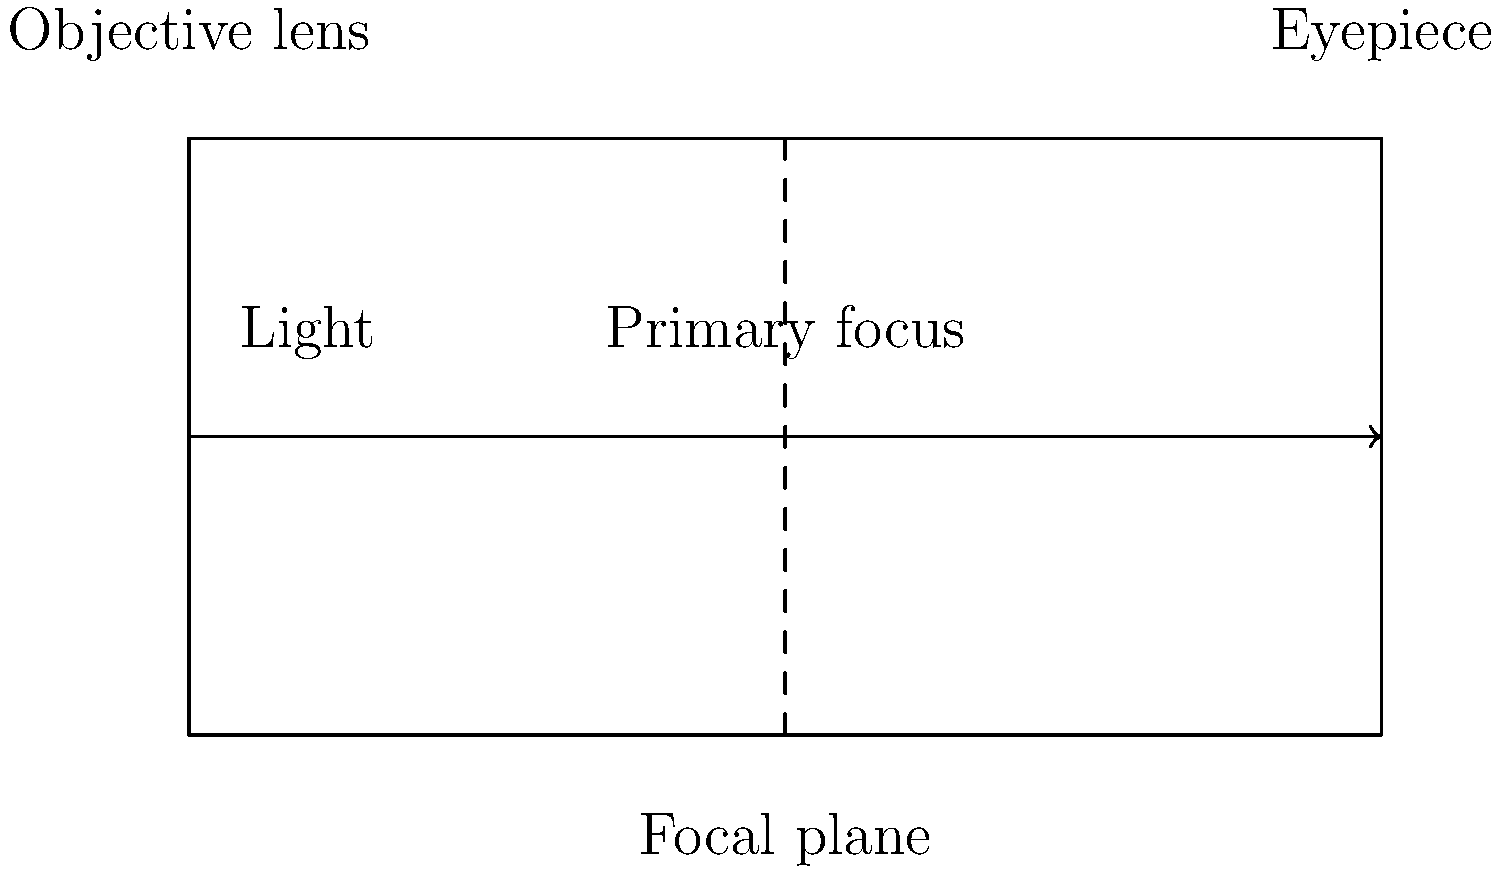In a refracting telescope, what is the purpose of the component labeled "Objective lens" in the diagram? To understand the purpose of the objective lens in a refracting telescope, let's break it down step-by-step:

1. Light collection: The objective lens is the first component that incoming light encounters in a refracting telescope. Its primary purpose is to gather as much light as possible from distant celestial objects.

2. Light focusing: After collecting the light, the objective lens focuses it to create a clear image. This is similar to how a camera lens works to focus light onto the film or sensor.

3. Image formation: The focused light converges at a point called the focal plane, where a real image of the distant object is formed.

4. Magnification: The size of the objective lens determines the telescope's light-gathering power. A larger objective lens can collect more light, allowing for the observation of fainter objects.

5. Resolution: The objective lens also plays a crucial role in determining the telescope's resolving power, which is its ability to distinguish between two closely spaced objects.

6. Primary optical element: In a refracting telescope, the objective lens serves as the primary optical element, unlike in reflecting telescopes that use mirrors.

7. Relation to filmmaking: As a film enthusiast, you can think of the objective lens as the "wide-angle lens" of the telescope, capturing the initial, broad view of the celestial scene.

The eyepiece, located at the opposite end of the telescope, then acts as a magnifying glass to enlarge the image formed by the objective lens, similar to how different camera lenses can change the perspective and focus of a shot in filmmaking.
Answer: To collect and focus light from distant objects 